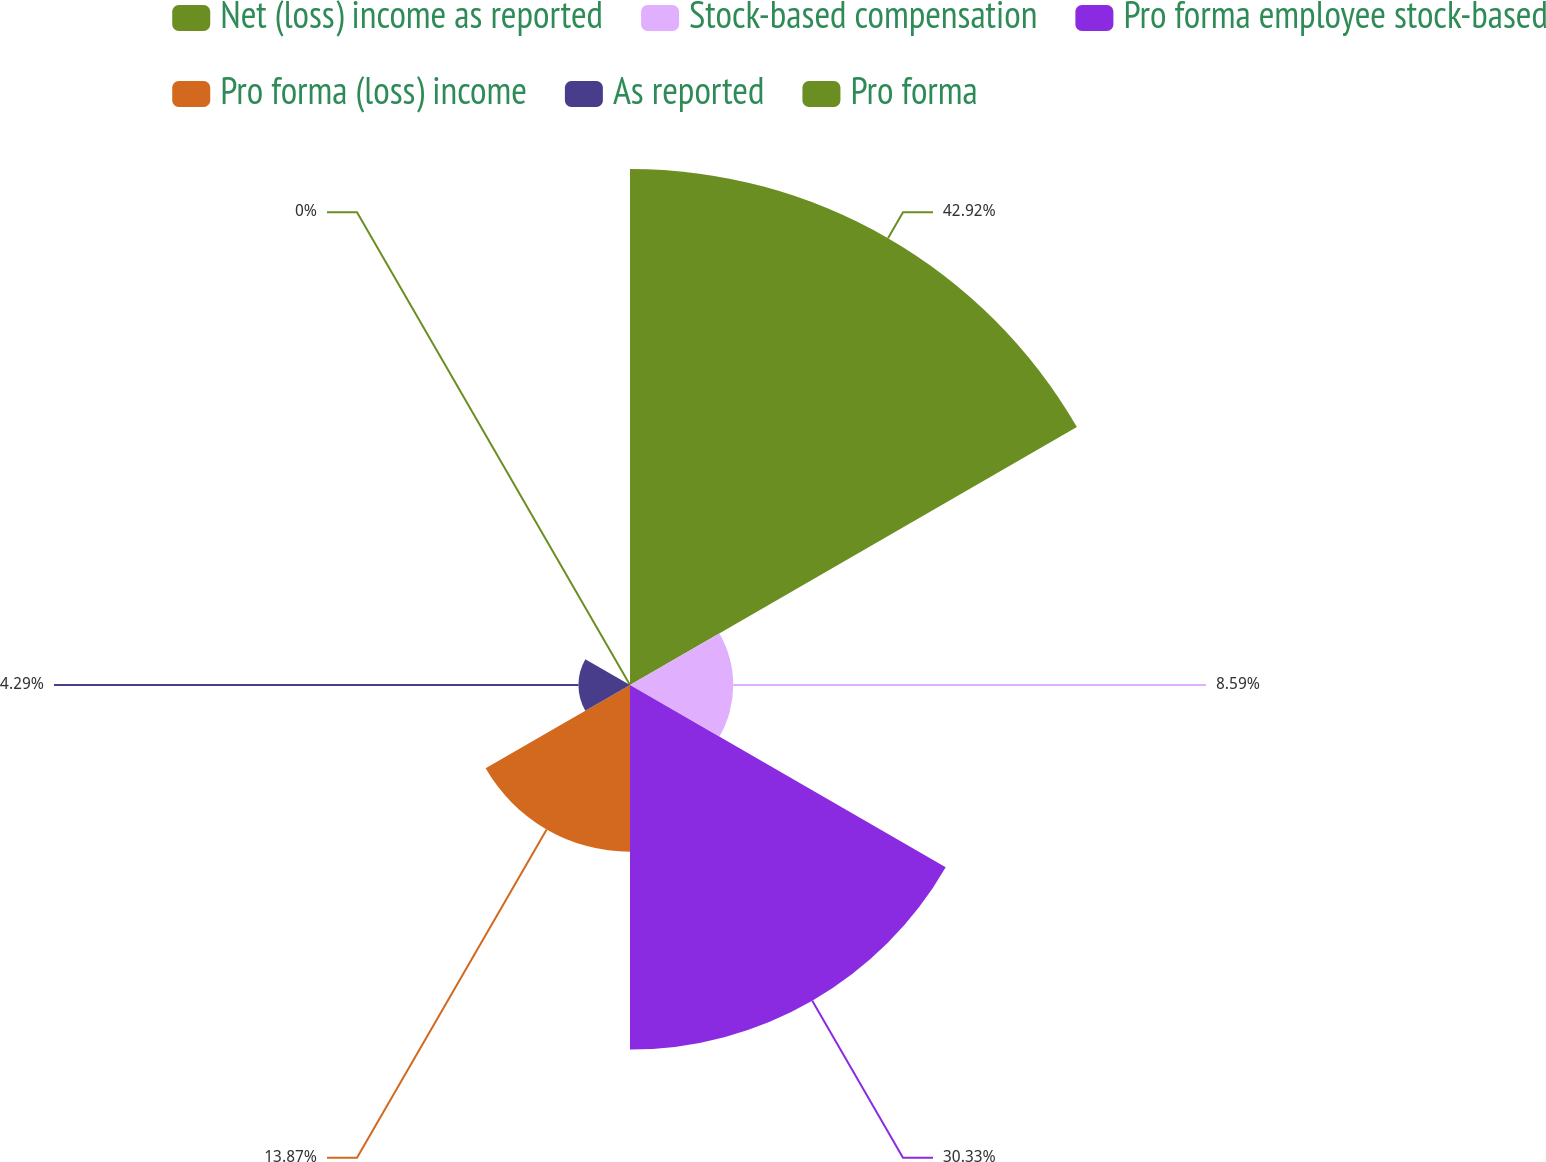Convert chart. <chart><loc_0><loc_0><loc_500><loc_500><pie_chart><fcel>Net (loss) income as reported<fcel>Stock-based compensation<fcel>Pro forma employee stock-based<fcel>Pro forma (loss) income<fcel>As reported<fcel>Pro forma<nl><fcel>42.93%<fcel>8.59%<fcel>30.33%<fcel>13.87%<fcel>4.29%<fcel>0.0%<nl></chart> 